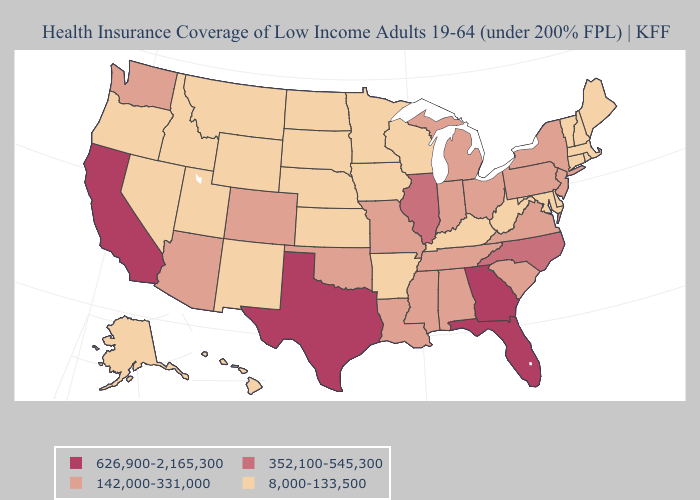Is the legend a continuous bar?
Quick response, please. No. Does the map have missing data?
Write a very short answer. No. Name the states that have a value in the range 352,100-545,300?
Keep it brief. Illinois, North Carolina. Name the states that have a value in the range 8,000-133,500?
Quick response, please. Alaska, Arkansas, Connecticut, Delaware, Hawaii, Idaho, Iowa, Kansas, Kentucky, Maine, Maryland, Massachusetts, Minnesota, Montana, Nebraska, Nevada, New Hampshire, New Mexico, North Dakota, Oregon, Rhode Island, South Dakota, Utah, Vermont, West Virginia, Wisconsin, Wyoming. Which states hav the highest value in the West?
Quick response, please. California. Name the states that have a value in the range 626,900-2,165,300?
Short answer required. California, Florida, Georgia, Texas. What is the lowest value in the USA?
Quick response, please. 8,000-133,500. Among the states that border New Mexico , does Texas have the highest value?
Quick response, please. Yes. Is the legend a continuous bar?
Short answer required. No. Does Illinois have the lowest value in the USA?
Write a very short answer. No. How many symbols are there in the legend?
Write a very short answer. 4. What is the value of Tennessee?
Give a very brief answer. 142,000-331,000. How many symbols are there in the legend?
Give a very brief answer. 4. Which states hav the highest value in the Northeast?
Short answer required. New Jersey, New York, Pennsylvania. Does Florida have the highest value in the USA?
Short answer required. Yes. 